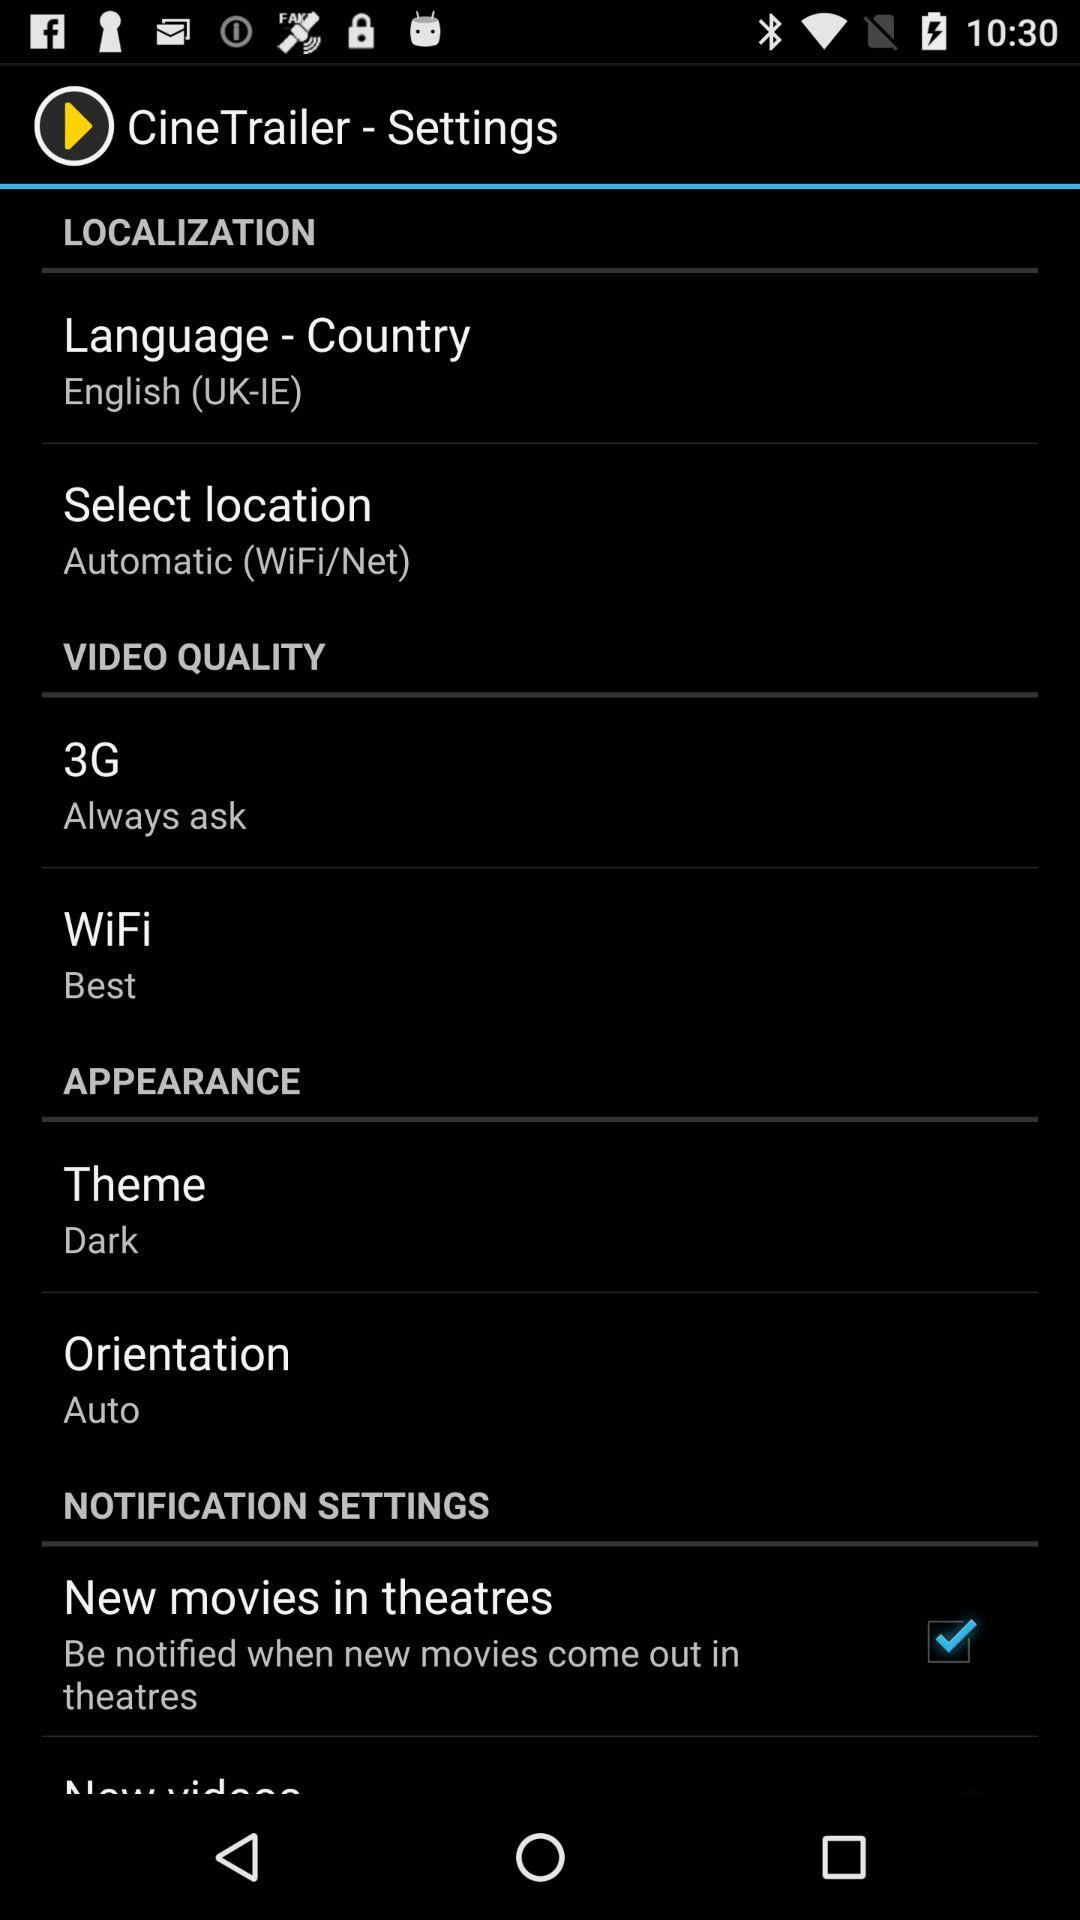What is the setting for "3G"? The setting for "3G" is "Always ask". 